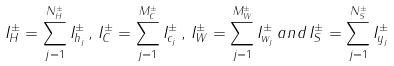Convert formula to latex. <formula><loc_0><loc_0><loc_500><loc_500>I ^ { \pm } _ { H } = \sum ^ { N ^ { \pm } _ { H } } _ { j = 1 } I _ { h _ { j } } ^ { \pm } \, , \, I ^ { \pm } _ { C } = \sum ^ { M ^ { \pm } _ { C } } _ { j = 1 } I _ { c _ { j } } ^ { \pm } \, , \, I ^ { \pm } _ { W } = \sum ^ { M ^ { \pm } _ { W } } _ { j = 1 } I _ { w _ { j } } ^ { \pm } \, a n d \, I ^ { \pm } _ { S } = \sum ^ { N ^ { \pm } _ { S } } _ { j = 1 } I _ { y _ { j } } ^ { \pm }</formula> 